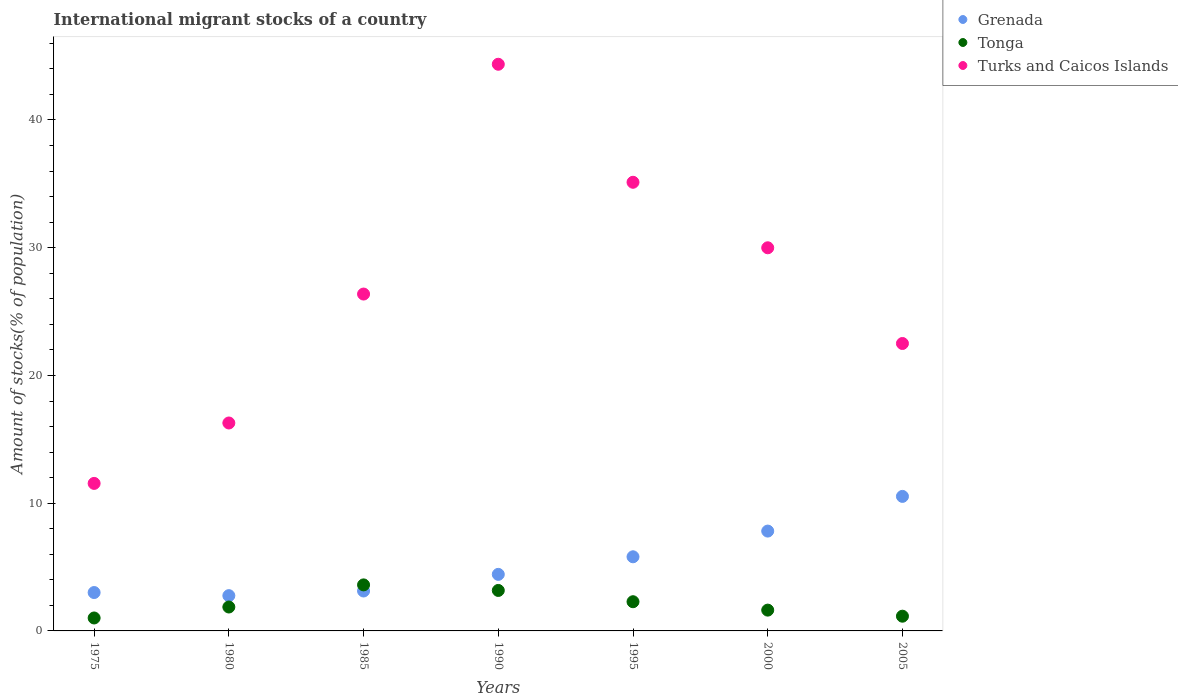What is the amount of stocks in in Turks and Caicos Islands in 2000?
Provide a short and direct response. 30. Across all years, what is the maximum amount of stocks in in Grenada?
Give a very brief answer. 10.53. Across all years, what is the minimum amount of stocks in in Grenada?
Provide a short and direct response. 2.76. In which year was the amount of stocks in in Grenada maximum?
Your answer should be very brief. 2005. In which year was the amount of stocks in in Turks and Caicos Islands minimum?
Keep it short and to the point. 1975. What is the total amount of stocks in in Grenada in the graph?
Ensure brevity in your answer.  37.47. What is the difference between the amount of stocks in in Grenada in 1980 and that in 1990?
Offer a terse response. -1.67. What is the difference between the amount of stocks in in Turks and Caicos Islands in 1995 and the amount of stocks in in Grenada in 2000?
Make the answer very short. 27.31. What is the average amount of stocks in in Tonga per year?
Provide a short and direct response. 2.1. In the year 2000, what is the difference between the amount of stocks in in Turks and Caicos Islands and amount of stocks in in Tonga?
Ensure brevity in your answer.  28.37. In how many years, is the amount of stocks in in Turks and Caicos Islands greater than 22 %?
Provide a short and direct response. 5. What is the ratio of the amount of stocks in in Tonga in 1995 to that in 2000?
Your answer should be very brief. 1.4. What is the difference between the highest and the second highest amount of stocks in in Turks and Caicos Islands?
Ensure brevity in your answer.  9.24. What is the difference between the highest and the lowest amount of stocks in in Turks and Caicos Islands?
Provide a short and direct response. 32.81. In how many years, is the amount of stocks in in Turks and Caicos Islands greater than the average amount of stocks in in Turks and Caicos Islands taken over all years?
Give a very brief answer. 3. Is the sum of the amount of stocks in in Tonga in 1980 and 1990 greater than the maximum amount of stocks in in Grenada across all years?
Offer a terse response. No. Does the amount of stocks in in Turks and Caicos Islands monotonically increase over the years?
Give a very brief answer. No. How many years are there in the graph?
Offer a terse response. 7. What is the difference between two consecutive major ticks on the Y-axis?
Your answer should be compact. 10. Where does the legend appear in the graph?
Your response must be concise. Top right. What is the title of the graph?
Your response must be concise. International migrant stocks of a country. What is the label or title of the Y-axis?
Keep it short and to the point. Amount of stocks(% of population). What is the Amount of stocks(% of population) in Grenada in 1975?
Offer a terse response. 3. What is the Amount of stocks(% of population) of Tonga in 1975?
Your response must be concise. 1.01. What is the Amount of stocks(% of population) in Turks and Caicos Islands in 1975?
Offer a terse response. 11.55. What is the Amount of stocks(% of population) in Grenada in 1980?
Your answer should be compact. 2.76. What is the Amount of stocks(% of population) of Tonga in 1980?
Offer a very short reply. 1.87. What is the Amount of stocks(% of population) in Turks and Caicos Islands in 1980?
Make the answer very short. 16.28. What is the Amount of stocks(% of population) of Grenada in 1985?
Offer a terse response. 3.13. What is the Amount of stocks(% of population) of Tonga in 1985?
Your response must be concise. 3.6. What is the Amount of stocks(% of population) in Turks and Caicos Islands in 1985?
Your answer should be very brief. 26.37. What is the Amount of stocks(% of population) of Grenada in 1990?
Your response must be concise. 4.43. What is the Amount of stocks(% of population) of Tonga in 1990?
Provide a short and direct response. 3.17. What is the Amount of stocks(% of population) in Turks and Caicos Islands in 1990?
Give a very brief answer. 44.36. What is the Amount of stocks(% of population) in Grenada in 1995?
Your response must be concise. 5.8. What is the Amount of stocks(% of population) in Tonga in 1995?
Your answer should be compact. 2.29. What is the Amount of stocks(% of population) in Turks and Caicos Islands in 1995?
Provide a short and direct response. 35.12. What is the Amount of stocks(% of population) of Grenada in 2000?
Keep it short and to the point. 7.82. What is the Amount of stocks(% of population) of Tonga in 2000?
Make the answer very short. 1.63. What is the Amount of stocks(% of population) in Turks and Caicos Islands in 2000?
Keep it short and to the point. 30. What is the Amount of stocks(% of population) in Grenada in 2005?
Make the answer very short. 10.53. What is the Amount of stocks(% of population) of Tonga in 2005?
Ensure brevity in your answer.  1.15. What is the Amount of stocks(% of population) in Turks and Caicos Islands in 2005?
Provide a succinct answer. 22.5. Across all years, what is the maximum Amount of stocks(% of population) in Grenada?
Your answer should be compact. 10.53. Across all years, what is the maximum Amount of stocks(% of population) of Tonga?
Offer a very short reply. 3.6. Across all years, what is the maximum Amount of stocks(% of population) of Turks and Caicos Islands?
Keep it short and to the point. 44.36. Across all years, what is the minimum Amount of stocks(% of population) of Grenada?
Offer a terse response. 2.76. Across all years, what is the minimum Amount of stocks(% of population) in Tonga?
Provide a short and direct response. 1.01. Across all years, what is the minimum Amount of stocks(% of population) of Turks and Caicos Islands?
Offer a very short reply. 11.55. What is the total Amount of stocks(% of population) in Grenada in the graph?
Make the answer very short. 37.47. What is the total Amount of stocks(% of population) in Tonga in the graph?
Ensure brevity in your answer.  14.72. What is the total Amount of stocks(% of population) in Turks and Caicos Islands in the graph?
Provide a short and direct response. 186.19. What is the difference between the Amount of stocks(% of population) in Grenada in 1975 and that in 1980?
Your answer should be very brief. 0.24. What is the difference between the Amount of stocks(% of population) of Tonga in 1975 and that in 1980?
Your answer should be very brief. -0.86. What is the difference between the Amount of stocks(% of population) of Turks and Caicos Islands in 1975 and that in 1980?
Your answer should be very brief. -4.73. What is the difference between the Amount of stocks(% of population) of Grenada in 1975 and that in 1985?
Offer a very short reply. -0.12. What is the difference between the Amount of stocks(% of population) in Tonga in 1975 and that in 1985?
Provide a short and direct response. -2.59. What is the difference between the Amount of stocks(% of population) of Turks and Caicos Islands in 1975 and that in 1985?
Give a very brief answer. -14.82. What is the difference between the Amount of stocks(% of population) of Grenada in 1975 and that in 1990?
Keep it short and to the point. -1.42. What is the difference between the Amount of stocks(% of population) of Tonga in 1975 and that in 1990?
Make the answer very short. -2.16. What is the difference between the Amount of stocks(% of population) of Turks and Caicos Islands in 1975 and that in 1990?
Make the answer very short. -32.81. What is the difference between the Amount of stocks(% of population) of Grenada in 1975 and that in 1995?
Ensure brevity in your answer.  -2.8. What is the difference between the Amount of stocks(% of population) in Tonga in 1975 and that in 1995?
Make the answer very short. -1.27. What is the difference between the Amount of stocks(% of population) in Turks and Caicos Islands in 1975 and that in 1995?
Provide a short and direct response. -23.58. What is the difference between the Amount of stocks(% of population) in Grenada in 1975 and that in 2000?
Your response must be concise. -4.81. What is the difference between the Amount of stocks(% of population) of Tonga in 1975 and that in 2000?
Ensure brevity in your answer.  -0.62. What is the difference between the Amount of stocks(% of population) of Turks and Caicos Islands in 1975 and that in 2000?
Ensure brevity in your answer.  -18.45. What is the difference between the Amount of stocks(% of population) in Grenada in 1975 and that in 2005?
Keep it short and to the point. -7.53. What is the difference between the Amount of stocks(% of population) in Tonga in 1975 and that in 2005?
Offer a very short reply. -0.14. What is the difference between the Amount of stocks(% of population) of Turks and Caicos Islands in 1975 and that in 2005?
Your answer should be compact. -10.95. What is the difference between the Amount of stocks(% of population) in Grenada in 1980 and that in 1985?
Offer a terse response. -0.36. What is the difference between the Amount of stocks(% of population) of Tonga in 1980 and that in 1985?
Offer a terse response. -1.73. What is the difference between the Amount of stocks(% of population) in Turks and Caicos Islands in 1980 and that in 1985?
Your response must be concise. -10.09. What is the difference between the Amount of stocks(% of population) in Grenada in 1980 and that in 1990?
Give a very brief answer. -1.67. What is the difference between the Amount of stocks(% of population) of Tonga in 1980 and that in 1990?
Your response must be concise. -1.3. What is the difference between the Amount of stocks(% of population) in Turks and Caicos Islands in 1980 and that in 1990?
Provide a succinct answer. -28.08. What is the difference between the Amount of stocks(% of population) of Grenada in 1980 and that in 1995?
Offer a very short reply. -3.04. What is the difference between the Amount of stocks(% of population) in Tonga in 1980 and that in 1995?
Your answer should be very brief. -0.41. What is the difference between the Amount of stocks(% of population) in Turks and Caicos Islands in 1980 and that in 1995?
Your answer should be compact. -18.85. What is the difference between the Amount of stocks(% of population) of Grenada in 1980 and that in 2000?
Your answer should be very brief. -5.05. What is the difference between the Amount of stocks(% of population) of Tonga in 1980 and that in 2000?
Make the answer very short. 0.24. What is the difference between the Amount of stocks(% of population) in Turks and Caicos Islands in 1980 and that in 2000?
Give a very brief answer. -13.72. What is the difference between the Amount of stocks(% of population) in Grenada in 1980 and that in 2005?
Your answer should be compact. -7.77. What is the difference between the Amount of stocks(% of population) of Tonga in 1980 and that in 2005?
Give a very brief answer. 0.72. What is the difference between the Amount of stocks(% of population) in Turks and Caicos Islands in 1980 and that in 2005?
Provide a short and direct response. -6.22. What is the difference between the Amount of stocks(% of population) in Grenada in 1985 and that in 1990?
Your answer should be very brief. -1.3. What is the difference between the Amount of stocks(% of population) in Tonga in 1985 and that in 1990?
Provide a succinct answer. 0.44. What is the difference between the Amount of stocks(% of population) in Turks and Caicos Islands in 1985 and that in 1990?
Ensure brevity in your answer.  -17.99. What is the difference between the Amount of stocks(% of population) of Grenada in 1985 and that in 1995?
Your response must be concise. -2.68. What is the difference between the Amount of stocks(% of population) of Tonga in 1985 and that in 1995?
Keep it short and to the point. 1.32. What is the difference between the Amount of stocks(% of population) in Turks and Caicos Islands in 1985 and that in 1995?
Your answer should be compact. -8.75. What is the difference between the Amount of stocks(% of population) in Grenada in 1985 and that in 2000?
Your answer should be compact. -4.69. What is the difference between the Amount of stocks(% of population) in Tonga in 1985 and that in 2000?
Your answer should be very brief. 1.98. What is the difference between the Amount of stocks(% of population) in Turks and Caicos Islands in 1985 and that in 2000?
Offer a terse response. -3.62. What is the difference between the Amount of stocks(% of population) of Grenada in 1985 and that in 2005?
Make the answer very short. -7.41. What is the difference between the Amount of stocks(% of population) of Tonga in 1985 and that in 2005?
Provide a short and direct response. 2.45. What is the difference between the Amount of stocks(% of population) in Turks and Caicos Islands in 1985 and that in 2005?
Provide a short and direct response. 3.87. What is the difference between the Amount of stocks(% of population) of Grenada in 1990 and that in 1995?
Your response must be concise. -1.38. What is the difference between the Amount of stocks(% of population) of Tonga in 1990 and that in 1995?
Give a very brief answer. 0.88. What is the difference between the Amount of stocks(% of population) in Turks and Caicos Islands in 1990 and that in 1995?
Offer a very short reply. 9.24. What is the difference between the Amount of stocks(% of population) of Grenada in 1990 and that in 2000?
Give a very brief answer. -3.39. What is the difference between the Amount of stocks(% of population) in Tonga in 1990 and that in 2000?
Keep it short and to the point. 1.54. What is the difference between the Amount of stocks(% of population) in Turks and Caicos Islands in 1990 and that in 2000?
Provide a succinct answer. 14.37. What is the difference between the Amount of stocks(% of population) in Grenada in 1990 and that in 2005?
Give a very brief answer. -6.1. What is the difference between the Amount of stocks(% of population) in Tonga in 1990 and that in 2005?
Your answer should be very brief. 2.02. What is the difference between the Amount of stocks(% of population) of Turks and Caicos Islands in 1990 and that in 2005?
Give a very brief answer. 21.86. What is the difference between the Amount of stocks(% of population) in Grenada in 1995 and that in 2000?
Provide a succinct answer. -2.01. What is the difference between the Amount of stocks(% of population) of Tonga in 1995 and that in 2000?
Your answer should be compact. 0.66. What is the difference between the Amount of stocks(% of population) in Turks and Caicos Islands in 1995 and that in 2000?
Give a very brief answer. 5.13. What is the difference between the Amount of stocks(% of population) of Grenada in 1995 and that in 2005?
Ensure brevity in your answer.  -4.73. What is the difference between the Amount of stocks(% of population) in Tonga in 1995 and that in 2005?
Ensure brevity in your answer.  1.13. What is the difference between the Amount of stocks(% of population) in Turks and Caicos Islands in 1995 and that in 2005?
Make the answer very short. 12.62. What is the difference between the Amount of stocks(% of population) of Grenada in 2000 and that in 2005?
Make the answer very short. -2.72. What is the difference between the Amount of stocks(% of population) of Tonga in 2000 and that in 2005?
Offer a very short reply. 0.48. What is the difference between the Amount of stocks(% of population) in Turks and Caicos Islands in 2000 and that in 2005?
Give a very brief answer. 7.49. What is the difference between the Amount of stocks(% of population) of Grenada in 1975 and the Amount of stocks(% of population) of Tonga in 1980?
Make the answer very short. 1.13. What is the difference between the Amount of stocks(% of population) of Grenada in 1975 and the Amount of stocks(% of population) of Turks and Caicos Islands in 1980?
Provide a short and direct response. -13.27. What is the difference between the Amount of stocks(% of population) in Tonga in 1975 and the Amount of stocks(% of population) in Turks and Caicos Islands in 1980?
Keep it short and to the point. -15.27. What is the difference between the Amount of stocks(% of population) of Grenada in 1975 and the Amount of stocks(% of population) of Tonga in 1985?
Ensure brevity in your answer.  -0.6. What is the difference between the Amount of stocks(% of population) in Grenada in 1975 and the Amount of stocks(% of population) in Turks and Caicos Islands in 1985?
Ensure brevity in your answer.  -23.37. What is the difference between the Amount of stocks(% of population) in Tonga in 1975 and the Amount of stocks(% of population) in Turks and Caicos Islands in 1985?
Offer a terse response. -25.36. What is the difference between the Amount of stocks(% of population) of Grenada in 1975 and the Amount of stocks(% of population) of Tonga in 1990?
Give a very brief answer. -0.16. What is the difference between the Amount of stocks(% of population) in Grenada in 1975 and the Amount of stocks(% of population) in Turks and Caicos Islands in 1990?
Provide a short and direct response. -41.36. What is the difference between the Amount of stocks(% of population) of Tonga in 1975 and the Amount of stocks(% of population) of Turks and Caicos Islands in 1990?
Keep it short and to the point. -43.35. What is the difference between the Amount of stocks(% of population) of Grenada in 1975 and the Amount of stocks(% of population) of Tonga in 1995?
Provide a short and direct response. 0.72. What is the difference between the Amount of stocks(% of population) of Grenada in 1975 and the Amount of stocks(% of population) of Turks and Caicos Islands in 1995?
Offer a terse response. -32.12. What is the difference between the Amount of stocks(% of population) of Tonga in 1975 and the Amount of stocks(% of population) of Turks and Caicos Islands in 1995?
Provide a succinct answer. -34.11. What is the difference between the Amount of stocks(% of population) in Grenada in 1975 and the Amount of stocks(% of population) in Tonga in 2000?
Offer a terse response. 1.38. What is the difference between the Amount of stocks(% of population) in Grenada in 1975 and the Amount of stocks(% of population) in Turks and Caicos Islands in 2000?
Your answer should be very brief. -26.99. What is the difference between the Amount of stocks(% of population) in Tonga in 1975 and the Amount of stocks(% of population) in Turks and Caicos Islands in 2000?
Keep it short and to the point. -28.98. What is the difference between the Amount of stocks(% of population) in Grenada in 1975 and the Amount of stocks(% of population) in Tonga in 2005?
Your answer should be very brief. 1.85. What is the difference between the Amount of stocks(% of population) of Grenada in 1975 and the Amount of stocks(% of population) of Turks and Caicos Islands in 2005?
Offer a very short reply. -19.5. What is the difference between the Amount of stocks(% of population) of Tonga in 1975 and the Amount of stocks(% of population) of Turks and Caicos Islands in 2005?
Your answer should be very brief. -21.49. What is the difference between the Amount of stocks(% of population) in Grenada in 1980 and the Amount of stocks(% of population) in Tonga in 1985?
Your answer should be compact. -0.84. What is the difference between the Amount of stocks(% of population) of Grenada in 1980 and the Amount of stocks(% of population) of Turks and Caicos Islands in 1985?
Offer a terse response. -23.61. What is the difference between the Amount of stocks(% of population) in Tonga in 1980 and the Amount of stocks(% of population) in Turks and Caicos Islands in 1985?
Make the answer very short. -24.5. What is the difference between the Amount of stocks(% of population) of Grenada in 1980 and the Amount of stocks(% of population) of Tonga in 1990?
Give a very brief answer. -0.41. What is the difference between the Amount of stocks(% of population) of Grenada in 1980 and the Amount of stocks(% of population) of Turks and Caicos Islands in 1990?
Offer a very short reply. -41.6. What is the difference between the Amount of stocks(% of population) in Tonga in 1980 and the Amount of stocks(% of population) in Turks and Caicos Islands in 1990?
Offer a terse response. -42.49. What is the difference between the Amount of stocks(% of population) in Grenada in 1980 and the Amount of stocks(% of population) in Tonga in 1995?
Ensure brevity in your answer.  0.48. What is the difference between the Amount of stocks(% of population) in Grenada in 1980 and the Amount of stocks(% of population) in Turks and Caicos Islands in 1995?
Provide a short and direct response. -32.36. What is the difference between the Amount of stocks(% of population) of Tonga in 1980 and the Amount of stocks(% of population) of Turks and Caicos Islands in 1995?
Give a very brief answer. -33.25. What is the difference between the Amount of stocks(% of population) in Grenada in 1980 and the Amount of stocks(% of population) in Tonga in 2000?
Ensure brevity in your answer.  1.13. What is the difference between the Amount of stocks(% of population) of Grenada in 1980 and the Amount of stocks(% of population) of Turks and Caicos Islands in 2000?
Provide a short and direct response. -27.23. What is the difference between the Amount of stocks(% of population) of Tonga in 1980 and the Amount of stocks(% of population) of Turks and Caicos Islands in 2000?
Offer a terse response. -28.12. What is the difference between the Amount of stocks(% of population) in Grenada in 1980 and the Amount of stocks(% of population) in Tonga in 2005?
Offer a very short reply. 1.61. What is the difference between the Amount of stocks(% of population) of Grenada in 1980 and the Amount of stocks(% of population) of Turks and Caicos Islands in 2005?
Give a very brief answer. -19.74. What is the difference between the Amount of stocks(% of population) in Tonga in 1980 and the Amount of stocks(% of population) in Turks and Caicos Islands in 2005?
Make the answer very short. -20.63. What is the difference between the Amount of stocks(% of population) in Grenada in 1985 and the Amount of stocks(% of population) in Tonga in 1990?
Provide a succinct answer. -0.04. What is the difference between the Amount of stocks(% of population) in Grenada in 1985 and the Amount of stocks(% of population) in Turks and Caicos Islands in 1990?
Your response must be concise. -41.24. What is the difference between the Amount of stocks(% of population) in Tonga in 1985 and the Amount of stocks(% of population) in Turks and Caicos Islands in 1990?
Your answer should be very brief. -40.76. What is the difference between the Amount of stocks(% of population) of Grenada in 1985 and the Amount of stocks(% of population) of Tonga in 1995?
Ensure brevity in your answer.  0.84. What is the difference between the Amount of stocks(% of population) in Grenada in 1985 and the Amount of stocks(% of population) in Turks and Caicos Islands in 1995?
Provide a succinct answer. -32. What is the difference between the Amount of stocks(% of population) in Tonga in 1985 and the Amount of stocks(% of population) in Turks and Caicos Islands in 1995?
Offer a terse response. -31.52. What is the difference between the Amount of stocks(% of population) in Grenada in 1985 and the Amount of stocks(% of population) in Tonga in 2000?
Provide a short and direct response. 1.5. What is the difference between the Amount of stocks(% of population) of Grenada in 1985 and the Amount of stocks(% of population) of Turks and Caicos Islands in 2000?
Offer a very short reply. -26.87. What is the difference between the Amount of stocks(% of population) of Tonga in 1985 and the Amount of stocks(% of population) of Turks and Caicos Islands in 2000?
Ensure brevity in your answer.  -26.39. What is the difference between the Amount of stocks(% of population) of Grenada in 1985 and the Amount of stocks(% of population) of Tonga in 2005?
Your answer should be very brief. 1.97. What is the difference between the Amount of stocks(% of population) of Grenada in 1985 and the Amount of stocks(% of population) of Turks and Caicos Islands in 2005?
Give a very brief answer. -19.38. What is the difference between the Amount of stocks(% of population) in Tonga in 1985 and the Amount of stocks(% of population) in Turks and Caicos Islands in 2005?
Offer a terse response. -18.9. What is the difference between the Amount of stocks(% of population) in Grenada in 1990 and the Amount of stocks(% of population) in Tonga in 1995?
Provide a succinct answer. 2.14. What is the difference between the Amount of stocks(% of population) of Grenada in 1990 and the Amount of stocks(% of population) of Turks and Caicos Islands in 1995?
Your answer should be very brief. -30.7. What is the difference between the Amount of stocks(% of population) in Tonga in 1990 and the Amount of stocks(% of population) in Turks and Caicos Islands in 1995?
Your answer should be compact. -31.96. What is the difference between the Amount of stocks(% of population) of Grenada in 1990 and the Amount of stocks(% of population) of Tonga in 2000?
Provide a succinct answer. 2.8. What is the difference between the Amount of stocks(% of population) in Grenada in 1990 and the Amount of stocks(% of population) in Turks and Caicos Islands in 2000?
Your answer should be very brief. -25.57. What is the difference between the Amount of stocks(% of population) in Tonga in 1990 and the Amount of stocks(% of population) in Turks and Caicos Islands in 2000?
Provide a succinct answer. -26.83. What is the difference between the Amount of stocks(% of population) in Grenada in 1990 and the Amount of stocks(% of population) in Tonga in 2005?
Your response must be concise. 3.27. What is the difference between the Amount of stocks(% of population) of Grenada in 1990 and the Amount of stocks(% of population) of Turks and Caicos Islands in 2005?
Provide a short and direct response. -18.08. What is the difference between the Amount of stocks(% of population) of Tonga in 1990 and the Amount of stocks(% of population) of Turks and Caicos Islands in 2005?
Offer a very short reply. -19.33. What is the difference between the Amount of stocks(% of population) in Grenada in 1995 and the Amount of stocks(% of population) in Tonga in 2000?
Make the answer very short. 4.18. What is the difference between the Amount of stocks(% of population) in Grenada in 1995 and the Amount of stocks(% of population) in Turks and Caicos Islands in 2000?
Offer a very short reply. -24.19. What is the difference between the Amount of stocks(% of population) in Tonga in 1995 and the Amount of stocks(% of population) in Turks and Caicos Islands in 2000?
Provide a short and direct response. -27.71. What is the difference between the Amount of stocks(% of population) in Grenada in 1995 and the Amount of stocks(% of population) in Tonga in 2005?
Offer a very short reply. 4.65. What is the difference between the Amount of stocks(% of population) in Grenada in 1995 and the Amount of stocks(% of population) in Turks and Caicos Islands in 2005?
Make the answer very short. -16.7. What is the difference between the Amount of stocks(% of population) of Tonga in 1995 and the Amount of stocks(% of population) of Turks and Caicos Islands in 2005?
Provide a succinct answer. -20.22. What is the difference between the Amount of stocks(% of population) in Grenada in 2000 and the Amount of stocks(% of population) in Tonga in 2005?
Keep it short and to the point. 6.66. What is the difference between the Amount of stocks(% of population) in Grenada in 2000 and the Amount of stocks(% of population) in Turks and Caicos Islands in 2005?
Your response must be concise. -14.69. What is the difference between the Amount of stocks(% of population) of Tonga in 2000 and the Amount of stocks(% of population) of Turks and Caicos Islands in 2005?
Ensure brevity in your answer.  -20.87. What is the average Amount of stocks(% of population) of Grenada per year?
Your answer should be very brief. 5.35. What is the average Amount of stocks(% of population) in Tonga per year?
Provide a succinct answer. 2.1. What is the average Amount of stocks(% of population) of Turks and Caicos Islands per year?
Your response must be concise. 26.6. In the year 1975, what is the difference between the Amount of stocks(% of population) in Grenada and Amount of stocks(% of population) in Tonga?
Offer a very short reply. 1.99. In the year 1975, what is the difference between the Amount of stocks(% of population) in Grenada and Amount of stocks(% of population) in Turks and Caicos Islands?
Make the answer very short. -8.54. In the year 1975, what is the difference between the Amount of stocks(% of population) in Tonga and Amount of stocks(% of population) in Turks and Caicos Islands?
Provide a succinct answer. -10.54. In the year 1980, what is the difference between the Amount of stocks(% of population) in Grenada and Amount of stocks(% of population) in Tonga?
Offer a terse response. 0.89. In the year 1980, what is the difference between the Amount of stocks(% of population) in Grenada and Amount of stocks(% of population) in Turks and Caicos Islands?
Make the answer very short. -13.52. In the year 1980, what is the difference between the Amount of stocks(% of population) in Tonga and Amount of stocks(% of population) in Turks and Caicos Islands?
Offer a terse response. -14.41. In the year 1985, what is the difference between the Amount of stocks(% of population) in Grenada and Amount of stocks(% of population) in Tonga?
Ensure brevity in your answer.  -0.48. In the year 1985, what is the difference between the Amount of stocks(% of population) of Grenada and Amount of stocks(% of population) of Turks and Caicos Islands?
Your answer should be compact. -23.25. In the year 1985, what is the difference between the Amount of stocks(% of population) in Tonga and Amount of stocks(% of population) in Turks and Caicos Islands?
Your response must be concise. -22.77. In the year 1990, what is the difference between the Amount of stocks(% of population) of Grenada and Amount of stocks(% of population) of Tonga?
Your answer should be compact. 1.26. In the year 1990, what is the difference between the Amount of stocks(% of population) in Grenada and Amount of stocks(% of population) in Turks and Caicos Islands?
Provide a short and direct response. -39.94. In the year 1990, what is the difference between the Amount of stocks(% of population) of Tonga and Amount of stocks(% of population) of Turks and Caicos Islands?
Provide a short and direct response. -41.2. In the year 1995, what is the difference between the Amount of stocks(% of population) of Grenada and Amount of stocks(% of population) of Tonga?
Give a very brief answer. 3.52. In the year 1995, what is the difference between the Amount of stocks(% of population) of Grenada and Amount of stocks(% of population) of Turks and Caicos Islands?
Your answer should be compact. -29.32. In the year 1995, what is the difference between the Amount of stocks(% of population) of Tonga and Amount of stocks(% of population) of Turks and Caicos Islands?
Your answer should be very brief. -32.84. In the year 2000, what is the difference between the Amount of stocks(% of population) of Grenada and Amount of stocks(% of population) of Tonga?
Provide a succinct answer. 6.19. In the year 2000, what is the difference between the Amount of stocks(% of population) in Grenada and Amount of stocks(% of population) in Turks and Caicos Islands?
Your response must be concise. -22.18. In the year 2000, what is the difference between the Amount of stocks(% of population) of Tonga and Amount of stocks(% of population) of Turks and Caicos Islands?
Provide a short and direct response. -28.37. In the year 2005, what is the difference between the Amount of stocks(% of population) in Grenada and Amount of stocks(% of population) in Tonga?
Offer a terse response. 9.38. In the year 2005, what is the difference between the Amount of stocks(% of population) of Grenada and Amount of stocks(% of population) of Turks and Caicos Islands?
Your answer should be compact. -11.97. In the year 2005, what is the difference between the Amount of stocks(% of population) in Tonga and Amount of stocks(% of population) in Turks and Caicos Islands?
Offer a very short reply. -21.35. What is the ratio of the Amount of stocks(% of population) in Grenada in 1975 to that in 1980?
Keep it short and to the point. 1.09. What is the ratio of the Amount of stocks(% of population) of Tonga in 1975 to that in 1980?
Ensure brevity in your answer.  0.54. What is the ratio of the Amount of stocks(% of population) in Turks and Caicos Islands in 1975 to that in 1980?
Your answer should be very brief. 0.71. What is the ratio of the Amount of stocks(% of population) of Grenada in 1975 to that in 1985?
Your answer should be very brief. 0.96. What is the ratio of the Amount of stocks(% of population) in Tonga in 1975 to that in 1985?
Give a very brief answer. 0.28. What is the ratio of the Amount of stocks(% of population) of Turks and Caicos Islands in 1975 to that in 1985?
Provide a short and direct response. 0.44. What is the ratio of the Amount of stocks(% of population) of Grenada in 1975 to that in 1990?
Give a very brief answer. 0.68. What is the ratio of the Amount of stocks(% of population) in Tonga in 1975 to that in 1990?
Give a very brief answer. 0.32. What is the ratio of the Amount of stocks(% of population) of Turks and Caicos Islands in 1975 to that in 1990?
Your answer should be very brief. 0.26. What is the ratio of the Amount of stocks(% of population) of Grenada in 1975 to that in 1995?
Your response must be concise. 0.52. What is the ratio of the Amount of stocks(% of population) of Tonga in 1975 to that in 1995?
Keep it short and to the point. 0.44. What is the ratio of the Amount of stocks(% of population) of Turks and Caicos Islands in 1975 to that in 1995?
Your answer should be compact. 0.33. What is the ratio of the Amount of stocks(% of population) of Grenada in 1975 to that in 2000?
Make the answer very short. 0.38. What is the ratio of the Amount of stocks(% of population) of Tonga in 1975 to that in 2000?
Offer a very short reply. 0.62. What is the ratio of the Amount of stocks(% of population) in Turks and Caicos Islands in 1975 to that in 2000?
Offer a terse response. 0.39. What is the ratio of the Amount of stocks(% of population) in Grenada in 1975 to that in 2005?
Your answer should be very brief. 0.29. What is the ratio of the Amount of stocks(% of population) of Tonga in 1975 to that in 2005?
Your answer should be compact. 0.88. What is the ratio of the Amount of stocks(% of population) in Turks and Caicos Islands in 1975 to that in 2005?
Offer a very short reply. 0.51. What is the ratio of the Amount of stocks(% of population) in Grenada in 1980 to that in 1985?
Your answer should be compact. 0.88. What is the ratio of the Amount of stocks(% of population) of Tonga in 1980 to that in 1985?
Your response must be concise. 0.52. What is the ratio of the Amount of stocks(% of population) of Turks and Caicos Islands in 1980 to that in 1985?
Provide a short and direct response. 0.62. What is the ratio of the Amount of stocks(% of population) in Grenada in 1980 to that in 1990?
Provide a short and direct response. 0.62. What is the ratio of the Amount of stocks(% of population) in Tonga in 1980 to that in 1990?
Your answer should be very brief. 0.59. What is the ratio of the Amount of stocks(% of population) of Turks and Caicos Islands in 1980 to that in 1990?
Make the answer very short. 0.37. What is the ratio of the Amount of stocks(% of population) in Grenada in 1980 to that in 1995?
Offer a very short reply. 0.48. What is the ratio of the Amount of stocks(% of population) in Tonga in 1980 to that in 1995?
Make the answer very short. 0.82. What is the ratio of the Amount of stocks(% of population) in Turks and Caicos Islands in 1980 to that in 1995?
Make the answer very short. 0.46. What is the ratio of the Amount of stocks(% of population) in Grenada in 1980 to that in 2000?
Offer a terse response. 0.35. What is the ratio of the Amount of stocks(% of population) of Tonga in 1980 to that in 2000?
Keep it short and to the point. 1.15. What is the ratio of the Amount of stocks(% of population) of Turks and Caicos Islands in 1980 to that in 2000?
Your response must be concise. 0.54. What is the ratio of the Amount of stocks(% of population) in Grenada in 1980 to that in 2005?
Your answer should be very brief. 0.26. What is the ratio of the Amount of stocks(% of population) of Tonga in 1980 to that in 2005?
Your response must be concise. 1.62. What is the ratio of the Amount of stocks(% of population) in Turks and Caicos Islands in 1980 to that in 2005?
Offer a terse response. 0.72. What is the ratio of the Amount of stocks(% of population) in Grenada in 1985 to that in 1990?
Your answer should be compact. 0.71. What is the ratio of the Amount of stocks(% of population) in Tonga in 1985 to that in 1990?
Make the answer very short. 1.14. What is the ratio of the Amount of stocks(% of population) in Turks and Caicos Islands in 1985 to that in 1990?
Offer a very short reply. 0.59. What is the ratio of the Amount of stocks(% of population) of Grenada in 1985 to that in 1995?
Ensure brevity in your answer.  0.54. What is the ratio of the Amount of stocks(% of population) of Tonga in 1985 to that in 1995?
Your response must be concise. 1.58. What is the ratio of the Amount of stocks(% of population) of Turks and Caicos Islands in 1985 to that in 1995?
Your answer should be compact. 0.75. What is the ratio of the Amount of stocks(% of population) of Grenada in 1985 to that in 2000?
Your answer should be compact. 0.4. What is the ratio of the Amount of stocks(% of population) in Tonga in 1985 to that in 2000?
Provide a short and direct response. 2.21. What is the ratio of the Amount of stocks(% of population) in Turks and Caicos Islands in 1985 to that in 2000?
Your answer should be very brief. 0.88. What is the ratio of the Amount of stocks(% of population) in Grenada in 1985 to that in 2005?
Your answer should be compact. 0.3. What is the ratio of the Amount of stocks(% of population) in Tonga in 1985 to that in 2005?
Your response must be concise. 3.13. What is the ratio of the Amount of stocks(% of population) in Turks and Caicos Islands in 1985 to that in 2005?
Provide a succinct answer. 1.17. What is the ratio of the Amount of stocks(% of population) of Grenada in 1990 to that in 1995?
Offer a very short reply. 0.76. What is the ratio of the Amount of stocks(% of population) of Tonga in 1990 to that in 1995?
Offer a terse response. 1.39. What is the ratio of the Amount of stocks(% of population) in Turks and Caicos Islands in 1990 to that in 1995?
Provide a short and direct response. 1.26. What is the ratio of the Amount of stocks(% of population) of Grenada in 1990 to that in 2000?
Offer a very short reply. 0.57. What is the ratio of the Amount of stocks(% of population) of Tonga in 1990 to that in 2000?
Your response must be concise. 1.95. What is the ratio of the Amount of stocks(% of population) in Turks and Caicos Islands in 1990 to that in 2000?
Your answer should be compact. 1.48. What is the ratio of the Amount of stocks(% of population) in Grenada in 1990 to that in 2005?
Give a very brief answer. 0.42. What is the ratio of the Amount of stocks(% of population) in Tonga in 1990 to that in 2005?
Ensure brevity in your answer.  2.75. What is the ratio of the Amount of stocks(% of population) of Turks and Caicos Islands in 1990 to that in 2005?
Make the answer very short. 1.97. What is the ratio of the Amount of stocks(% of population) in Grenada in 1995 to that in 2000?
Your answer should be very brief. 0.74. What is the ratio of the Amount of stocks(% of population) of Tonga in 1995 to that in 2000?
Give a very brief answer. 1.4. What is the ratio of the Amount of stocks(% of population) of Turks and Caicos Islands in 1995 to that in 2000?
Your answer should be compact. 1.17. What is the ratio of the Amount of stocks(% of population) in Grenada in 1995 to that in 2005?
Your answer should be very brief. 0.55. What is the ratio of the Amount of stocks(% of population) in Tonga in 1995 to that in 2005?
Ensure brevity in your answer.  1.98. What is the ratio of the Amount of stocks(% of population) of Turks and Caicos Islands in 1995 to that in 2005?
Offer a very short reply. 1.56. What is the ratio of the Amount of stocks(% of population) of Grenada in 2000 to that in 2005?
Provide a short and direct response. 0.74. What is the ratio of the Amount of stocks(% of population) in Tonga in 2000 to that in 2005?
Your response must be concise. 1.41. What is the ratio of the Amount of stocks(% of population) in Turks and Caicos Islands in 2000 to that in 2005?
Your response must be concise. 1.33. What is the difference between the highest and the second highest Amount of stocks(% of population) in Grenada?
Your response must be concise. 2.72. What is the difference between the highest and the second highest Amount of stocks(% of population) in Tonga?
Offer a terse response. 0.44. What is the difference between the highest and the second highest Amount of stocks(% of population) in Turks and Caicos Islands?
Your response must be concise. 9.24. What is the difference between the highest and the lowest Amount of stocks(% of population) of Grenada?
Your response must be concise. 7.77. What is the difference between the highest and the lowest Amount of stocks(% of population) in Tonga?
Provide a short and direct response. 2.59. What is the difference between the highest and the lowest Amount of stocks(% of population) of Turks and Caicos Islands?
Offer a terse response. 32.81. 